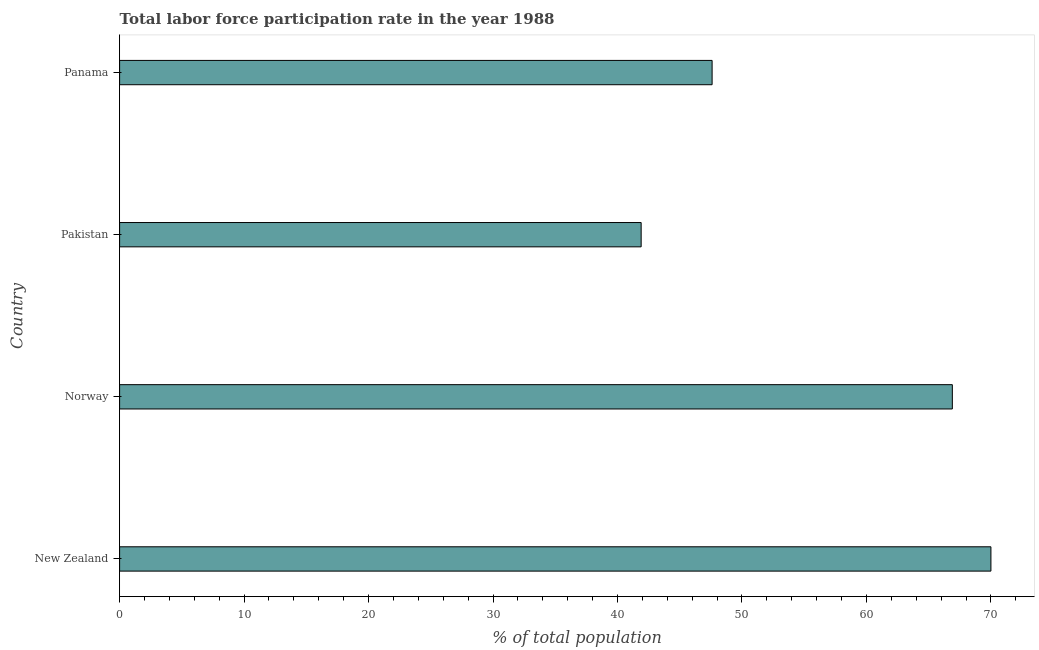What is the title of the graph?
Your answer should be very brief. Total labor force participation rate in the year 1988. What is the label or title of the X-axis?
Give a very brief answer. % of total population. What is the total labor force participation rate in Norway?
Your answer should be compact. 66.9. Across all countries, what is the minimum total labor force participation rate?
Provide a succinct answer. 41.9. In which country was the total labor force participation rate maximum?
Your response must be concise. New Zealand. What is the sum of the total labor force participation rate?
Your response must be concise. 226.4. What is the average total labor force participation rate per country?
Give a very brief answer. 56.6. What is the median total labor force participation rate?
Provide a short and direct response. 57.25. What is the ratio of the total labor force participation rate in New Zealand to that in Norway?
Your response must be concise. 1.05. Is the total labor force participation rate in Pakistan less than that in Panama?
Make the answer very short. Yes. Is the sum of the total labor force participation rate in New Zealand and Panama greater than the maximum total labor force participation rate across all countries?
Provide a succinct answer. Yes. What is the difference between the highest and the lowest total labor force participation rate?
Provide a succinct answer. 28.1. In how many countries, is the total labor force participation rate greater than the average total labor force participation rate taken over all countries?
Provide a succinct answer. 2. Are all the bars in the graph horizontal?
Your answer should be very brief. Yes. Are the values on the major ticks of X-axis written in scientific E-notation?
Your answer should be very brief. No. What is the % of total population in New Zealand?
Provide a succinct answer. 70. What is the % of total population of Norway?
Your answer should be very brief. 66.9. What is the % of total population in Pakistan?
Provide a succinct answer. 41.9. What is the % of total population in Panama?
Your response must be concise. 47.6. What is the difference between the % of total population in New Zealand and Norway?
Your answer should be very brief. 3.1. What is the difference between the % of total population in New Zealand and Pakistan?
Provide a succinct answer. 28.1. What is the difference between the % of total population in New Zealand and Panama?
Ensure brevity in your answer.  22.4. What is the difference between the % of total population in Norway and Panama?
Give a very brief answer. 19.3. What is the difference between the % of total population in Pakistan and Panama?
Ensure brevity in your answer.  -5.7. What is the ratio of the % of total population in New Zealand to that in Norway?
Your answer should be compact. 1.05. What is the ratio of the % of total population in New Zealand to that in Pakistan?
Provide a short and direct response. 1.67. What is the ratio of the % of total population in New Zealand to that in Panama?
Your answer should be very brief. 1.47. What is the ratio of the % of total population in Norway to that in Pakistan?
Your answer should be compact. 1.6. What is the ratio of the % of total population in Norway to that in Panama?
Provide a short and direct response. 1.41. 